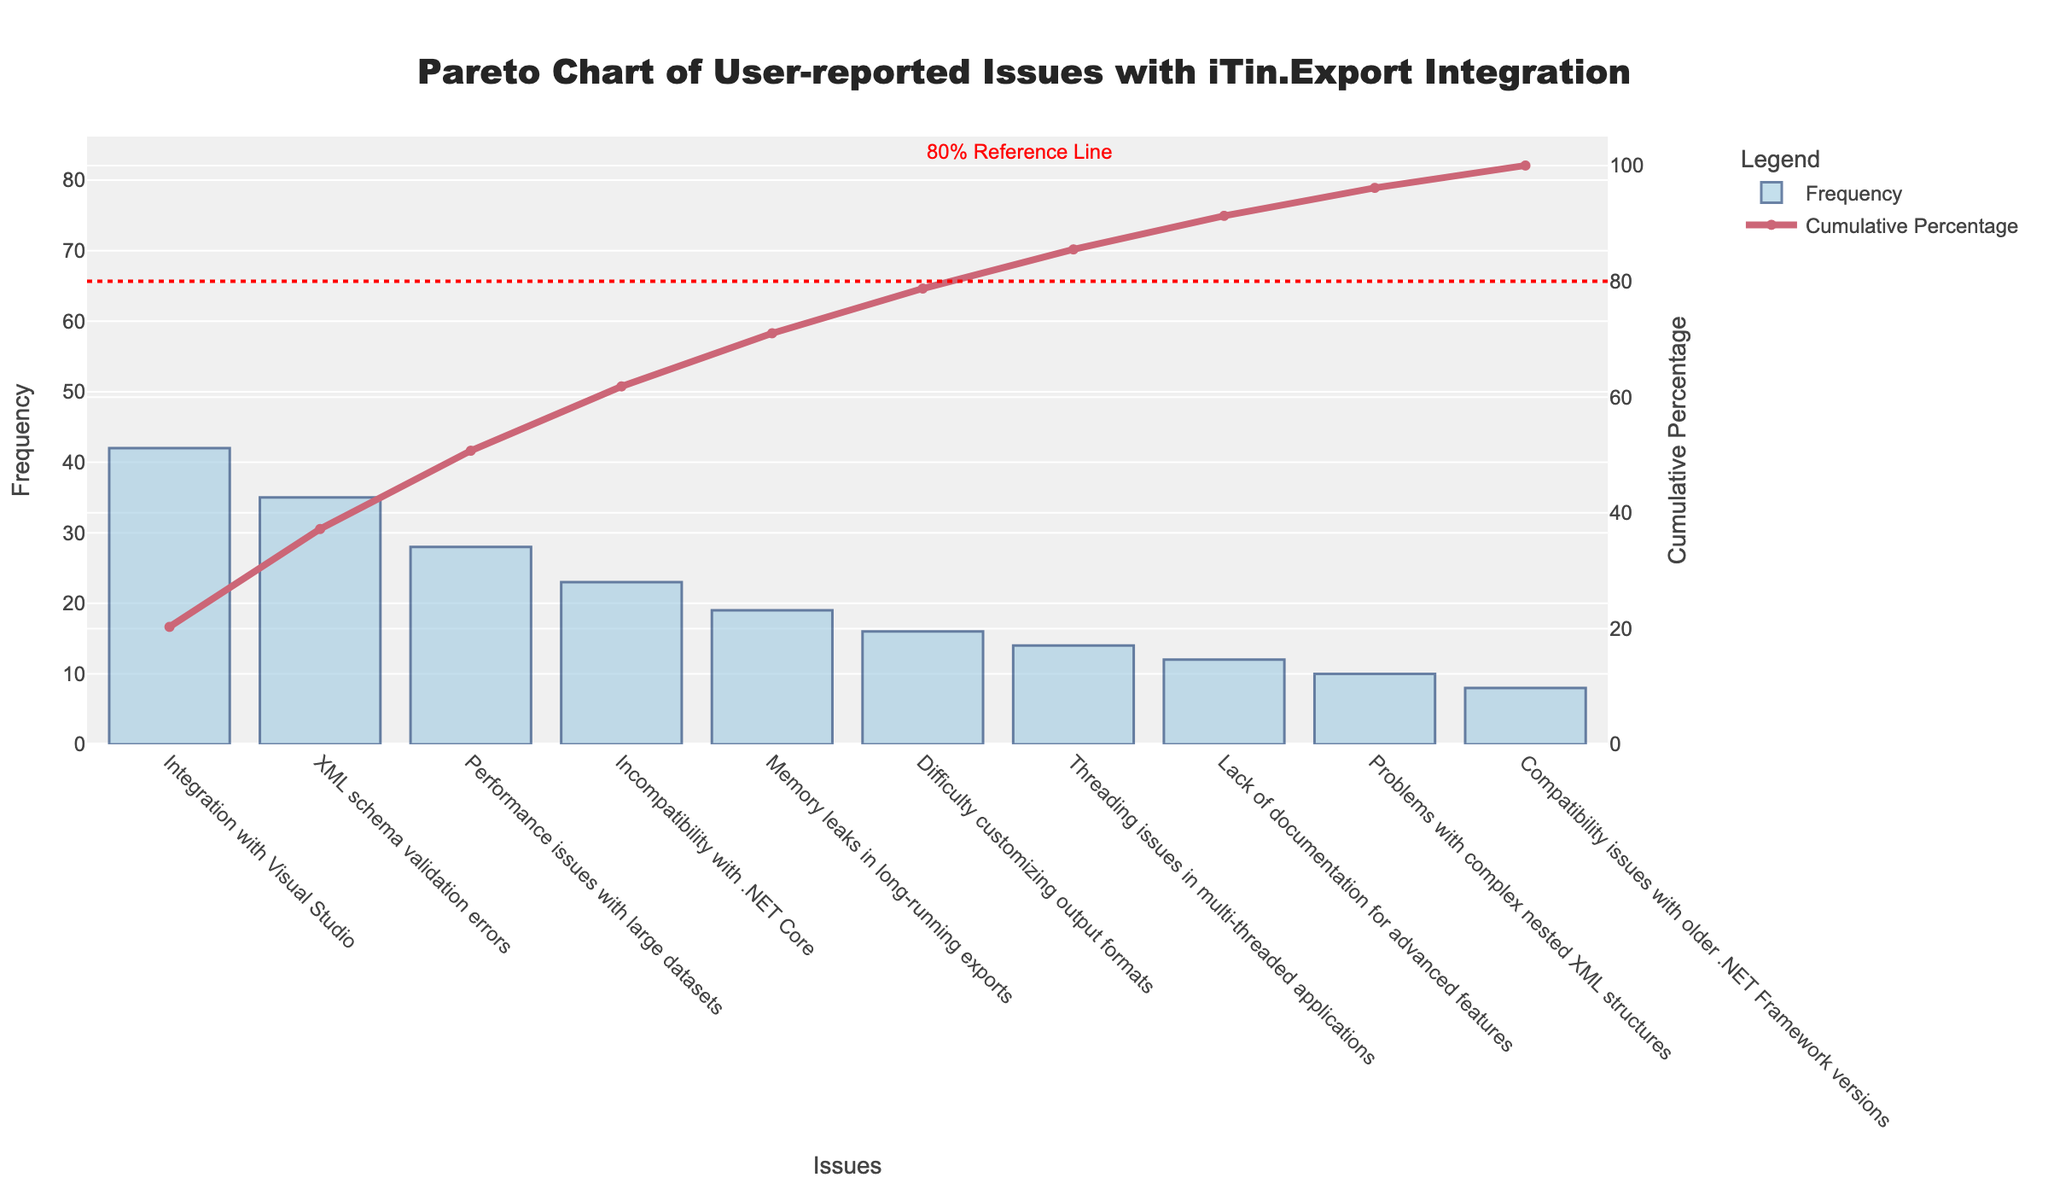What is the title of the figure? The title is located at the top of the plot and reads: 'Pareto Chart of User-reported Issues with iTin.Export Integration'.
Answer: Pareto Chart of User-reported Issues with iTin.Export Integration Which issue has the highest frequency? The bar representing 'Integration with Visual Studio' is the tallest in the figure, indicating that it has the highest frequency.
Answer: Integration with Visual Studio What is the cumulative percentage after the top four issues? Locate the cumulative percentage line for the top four bars ('Integration with Visual Studio', 'XML schema validation errors', 'Performance issues with large datasets', 'Incompatibility with .NET Core'). The cumulative percentage at this point is shown on the secondary y-axis, which reads approximately 68%.
Answer: 68% How many issues have a frequency greater than 20? Count the number of bars that extend above the 20 mark on the frequency (primary) y-axis. These issues are 'Integration with Visual Studio', 'XML schema validation errors', 'Performance issues with large datasets', and 'Incompatibility with .NET Core'.
Answer: 4 What percentage of issues does the 80% reference line represent? The red dotted line on the cumulative percentage y-axis indicates the 80% reference level, annotated as '80% Reference Line'.
Answer: 80% How many issues fall below the cumulative percentage of 80%? Identify the bars that fall before the cumulative percentage line crosses the 80% mark. This occurs after the first five issues: 'Integration with Visual Studio', 'XML schema validation errors', 'Performance issues with large datasets', 'Incompatibility with .NET Core', and 'Memory leaks in long-running exports'.
Answer: 5 Which issue contributes to the smallest cumulative percentage? Locate the bar with the least frequency, marked as 'Compatibility issues with older .NET Framework versions'. Check the corresponding point on the cumulative percentage line to verify it is the lowest.
Answer: Compatibility issues with older .NET Framework versions What is the combined frequency of the lowest three issues? The issues 'Lack of documentation for advanced features', 'Problems with complex nested XML structures', and 'Compatibility issues with older .NET Framework versions' have frequencies of 12, 10, and 8 respectively. Adding these values gives 12 + 10 + 8 = 30.
Answer: 30 